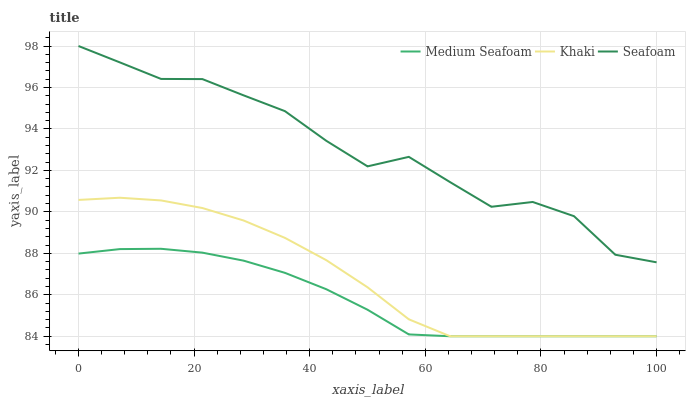Does Medium Seafoam have the minimum area under the curve?
Answer yes or no. Yes. Does Seafoam have the maximum area under the curve?
Answer yes or no. Yes. Does Seafoam have the minimum area under the curve?
Answer yes or no. No. Does Medium Seafoam have the maximum area under the curve?
Answer yes or no. No. Is Medium Seafoam the smoothest?
Answer yes or no. Yes. Is Seafoam the roughest?
Answer yes or no. Yes. Is Seafoam the smoothest?
Answer yes or no. No. Is Medium Seafoam the roughest?
Answer yes or no. No. Does Khaki have the lowest value?
Answer yes or no. Yes. Does Seafoam have the lowest value?
Answer yes or no. No. Does Seafoam have the highest value?
Answer yes or no. Yes. Does Medium Seafoam have the highest value?
Answer yes or no. No. Is Medium Seafoam less than Seafoam?
Answer yes or no. Yes. Is Seafoam greater than Medium Seafoam?
Answer yes or no. Yes. Does Khaki intersect Medium Seafoam?
Answer yes or no. Yes. Is Khaki less than Medium Seafoam?
Answer yes or no. No. Is Khaki greater than Medium Seafoam?
Answer yes or no. No. Does Medium Seafoam intersect Seafoam?
Answer yes or no. No. 